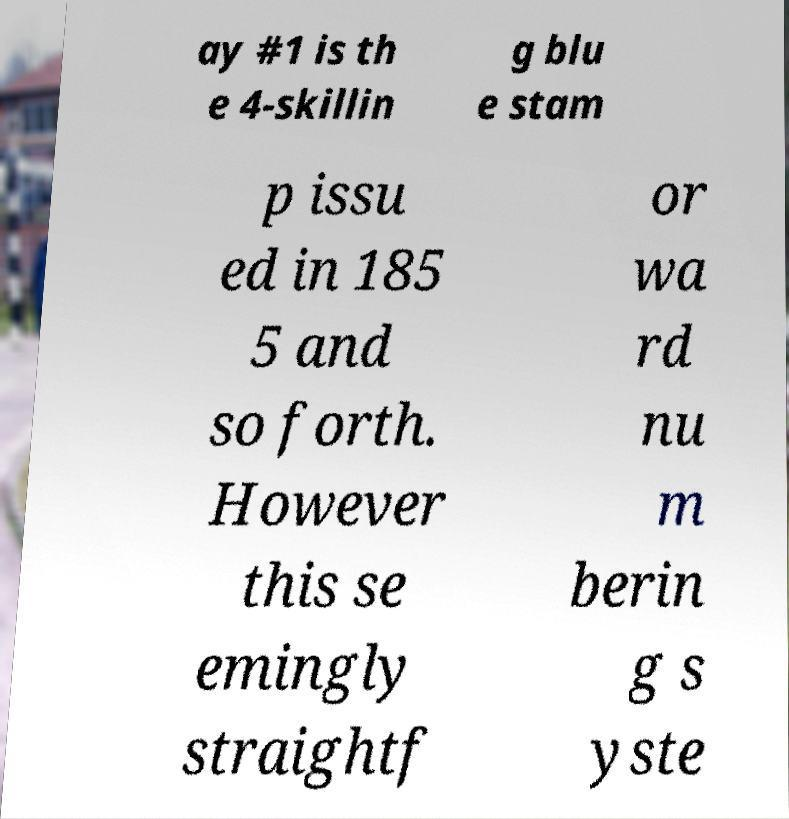What messages or text are displayed in this image? I need them in a readable, typed format. ay #1 is th e 4-skillin g blu e stam p issu ed in 185 5 and so forth. However this se emingly straightf or wa rd nu m berin g s yste 